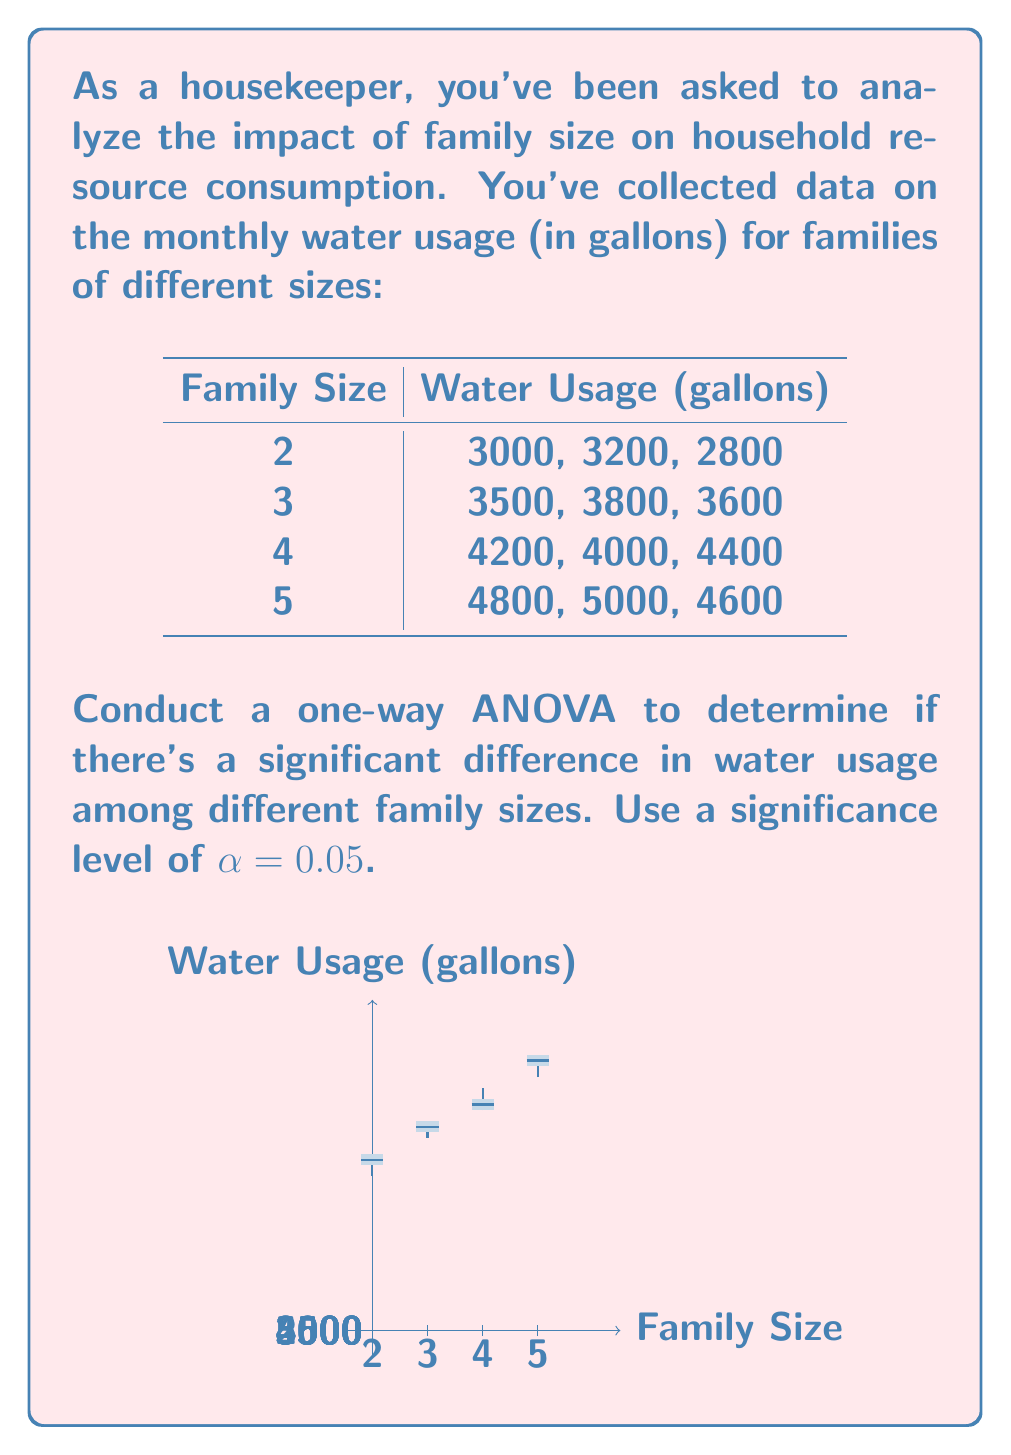Give your solution to this math problem. Let's conduct a one-way ANOVA to analyze the impact of family size on water usage:

Step 1: State the hypotheses
$H_0$: There is no significant difference in mean water usage among different family sizes.
$H_a$: There is a significant difference in mean water usage among different family sizes.

Step 2: Calculate the sum of squares
1. Total Sum of Squares (SST):
   $$SST = \sum_{i=1}^k \sum_{j=1}^n (X_{ij} - \bar{X})^2$$
   where $\bar{X}$ is the grand mean.

2. Between-group Sum of Squares (SSB):
   $$SSB = \sum_{i=1}^k n_i(\bar{X}_i - \bar{X})^2$$
   where $\bar{X}_i$ is the mean of each group.

3. Within-group Sum of Squares (SSW):
   $$SSW = SST - SSB$$

Step 3: Calculate degrees of freedom
df(total) = N - 1 = 12 - 1 = 11
df(between) = k - 1 = 4 - 1 = 3
df(within) = N - k = 12 - 4 = 8

Step 4: Calculate Mean Squares
MSB = SSB / df(between)
MSW = SSW / df(within)

Step 5: Calculate F-statistic
$$F = \frac{MSB}{MSW}$$

Step 6: Find the critical F-value
F(critical) = F(α, df(between), df(within)) = F(0.05, 3, 8)

Step 7: Make a decision
If F > F(critical), reject $H_0$. Otherwise, fail to reject $H_0$.

Calculations:
Grand Mean = 3908.33
SST = 5,054,166.67
SSB = 4,970,833.33
SSW = 83,333.33

MSB = 1,656,944.44
MSW = 10,416.67

F = 159.07
F(critical) = 4.07

Since F > F(critical), we reject the null hypothesis.
Answer: Reject $H_0$; F(3,8) = 159.07, p < 0.05 